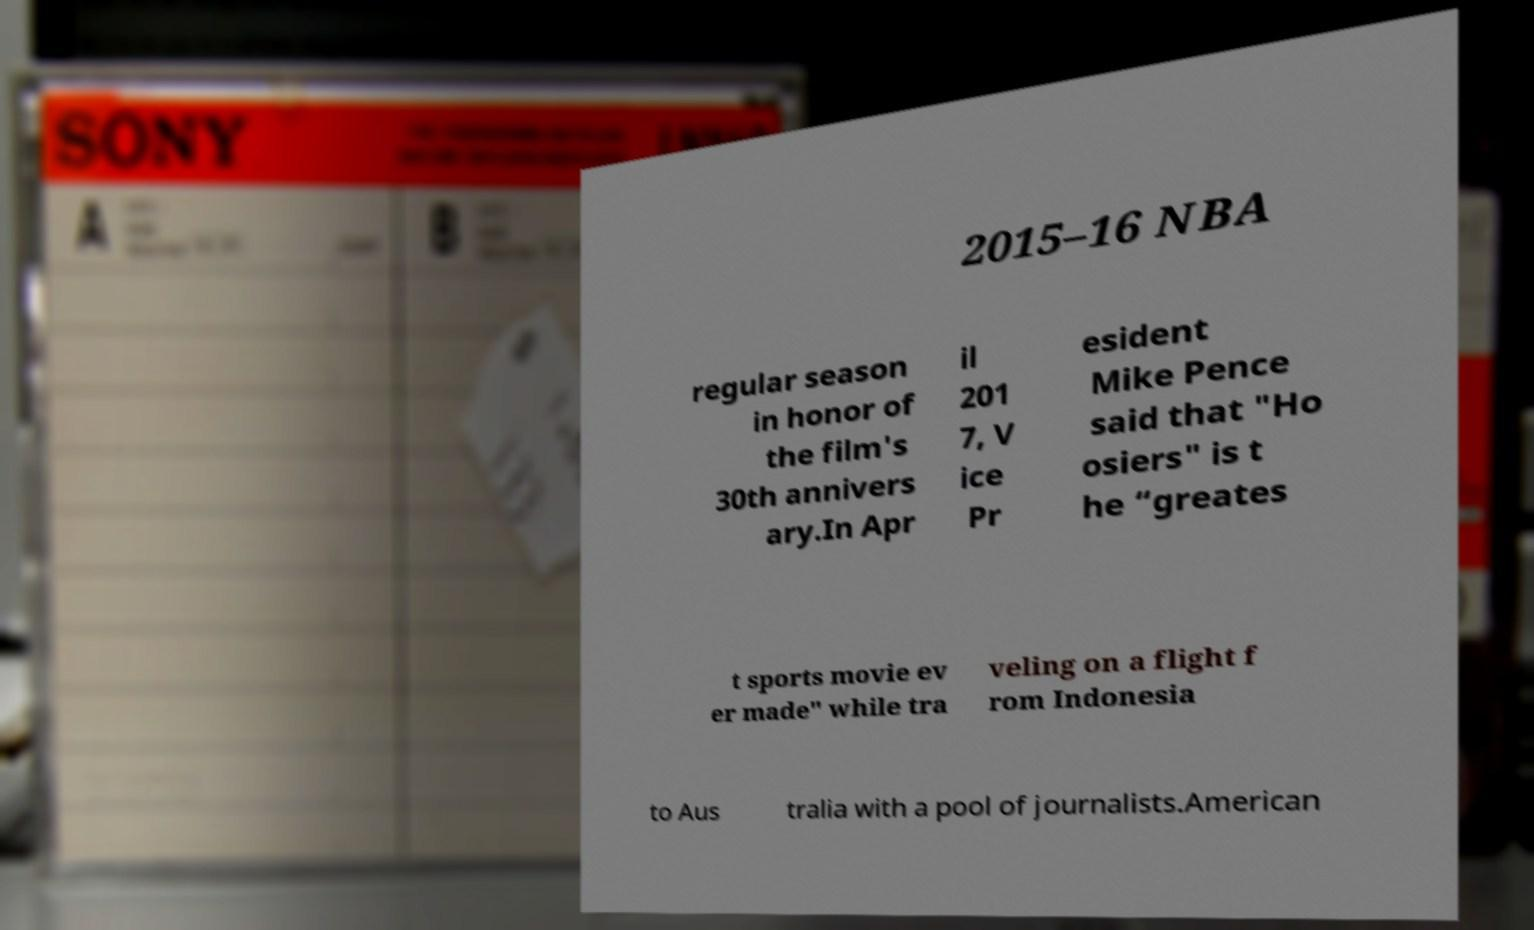Could you assist in decoding the text presented in this image and type it out clearly? 2015–16 NBA regular season in honor of the film's 30th annivers ary.In Apr il 201 7, V ice Pr esident Mike Pence said that "Ho osiers" is t he “greates t sports movie ev er made" while tra veling on a flight f rom Indonesia to Aus tralia with a pool of journalists.American 